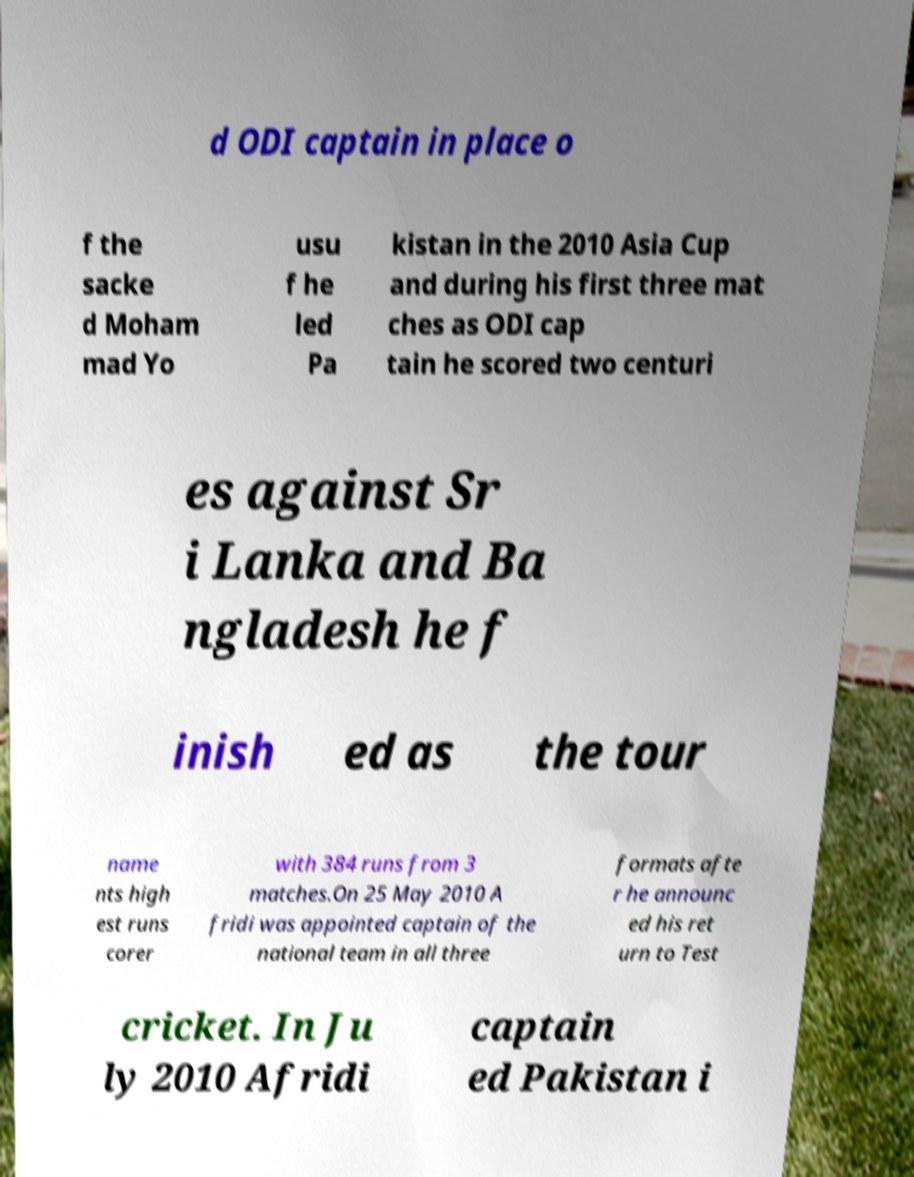Could you assist in decoding the text presented in this image and type it out clearly? d ODI captain in place o f the sacke d Moham mad Yo usu f he led Pa kistan in the 2010 Asia Cup and during his first three mat ches as ODI cap tain he scored two centuri es against Sr i Lanka and Ba ngladesh he f inish ed as the tour name nts high est runs corer with 384 runs from 3 matches.On 25 May 2010 A fridi was appointed captain of the national team in all three formats afte r he announc ed his ret urn to Test cricket. In Ju ly 2010 Afridi captain ed Pakistan i 